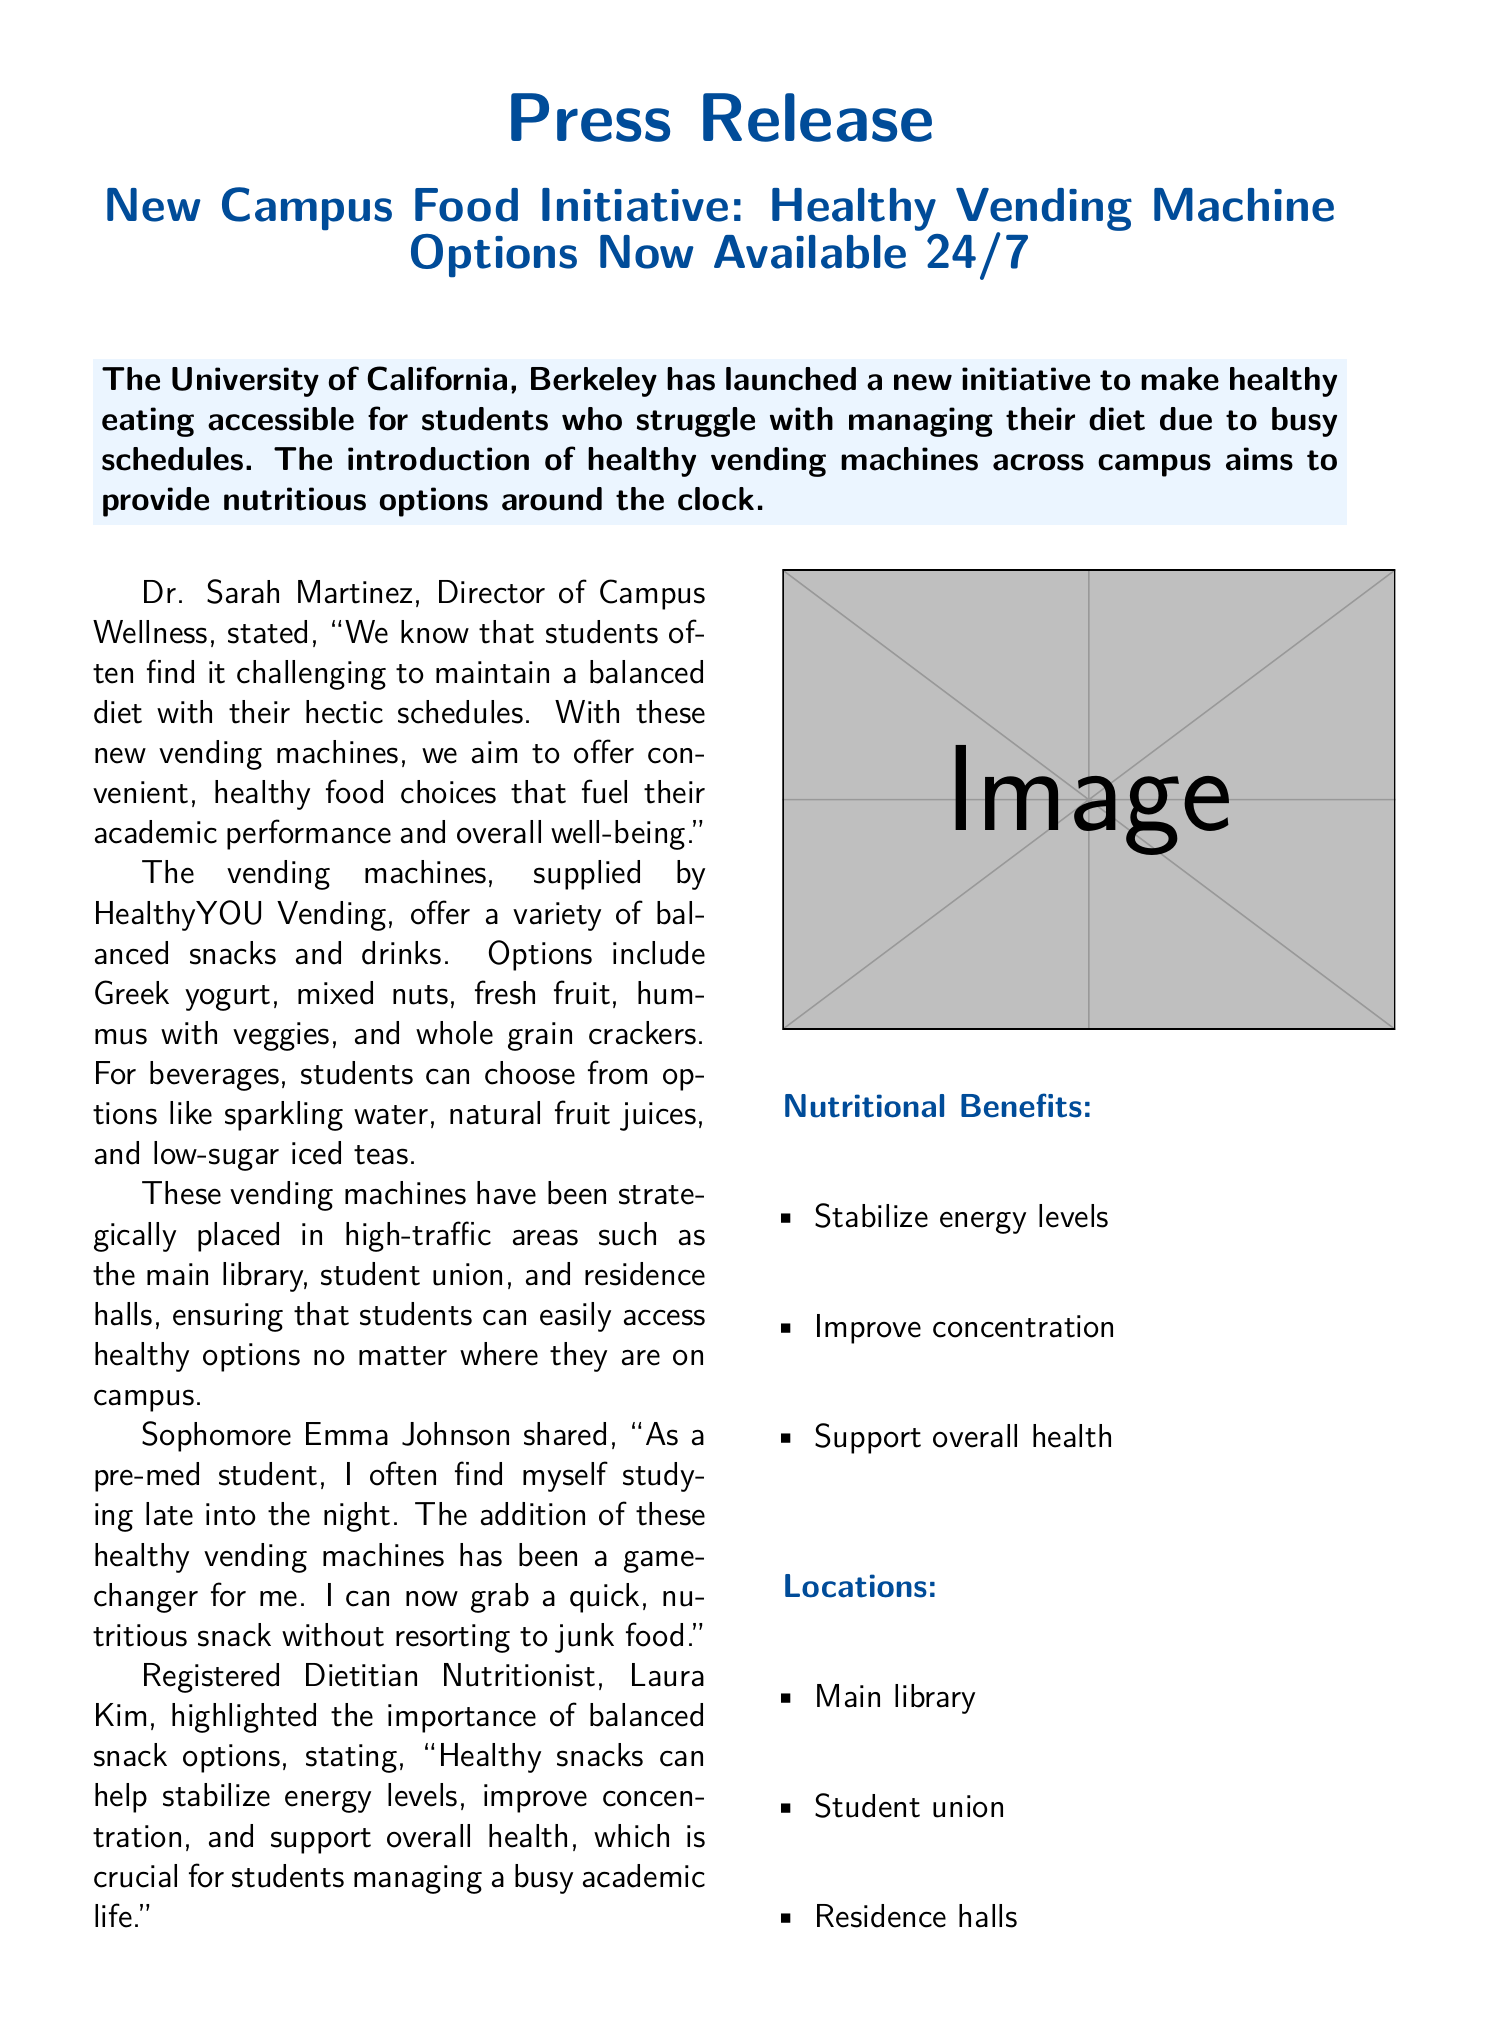what is the name of the initiative? The initiative is aimed at making healthy eating accessible for students.
Answer: Healthy Vending Machine Options who is the Director of Campus Wellness? The document mentions the title and name of the individual in charge of campus wellness.
Answer: Dr. Sarah Martinez what types of snacks are available in the vending machines? The document lists specific examples of snack options provided by the vending machines.
Answer: Greek yogurt, mixed nuts, fresh fruit, hummus with veggies, whole grain crackers where are the vending machines located? The document provides a list of specific locations for the vending machines on campus.
Answer: Main library, student union, residence halls why are healthy snacks important according to Laura Kim? The answer can be found in the statement made by Laura Kim regarding the significance of healthy snacks.
Answer: Stabilize energy levels, improve concentration, support overall health how many areas are mentioned as vending machine locations? The document indicates the number of specific locations where the machines can be found.
Answer: Three what organization supplied the vending machines? The document credits the supplier of the vending machines for the initiative.
Answer: HealthyYOU Vending what time are vending machines available? The document specifies the availability of the vending machines.
Answer: 24/7 